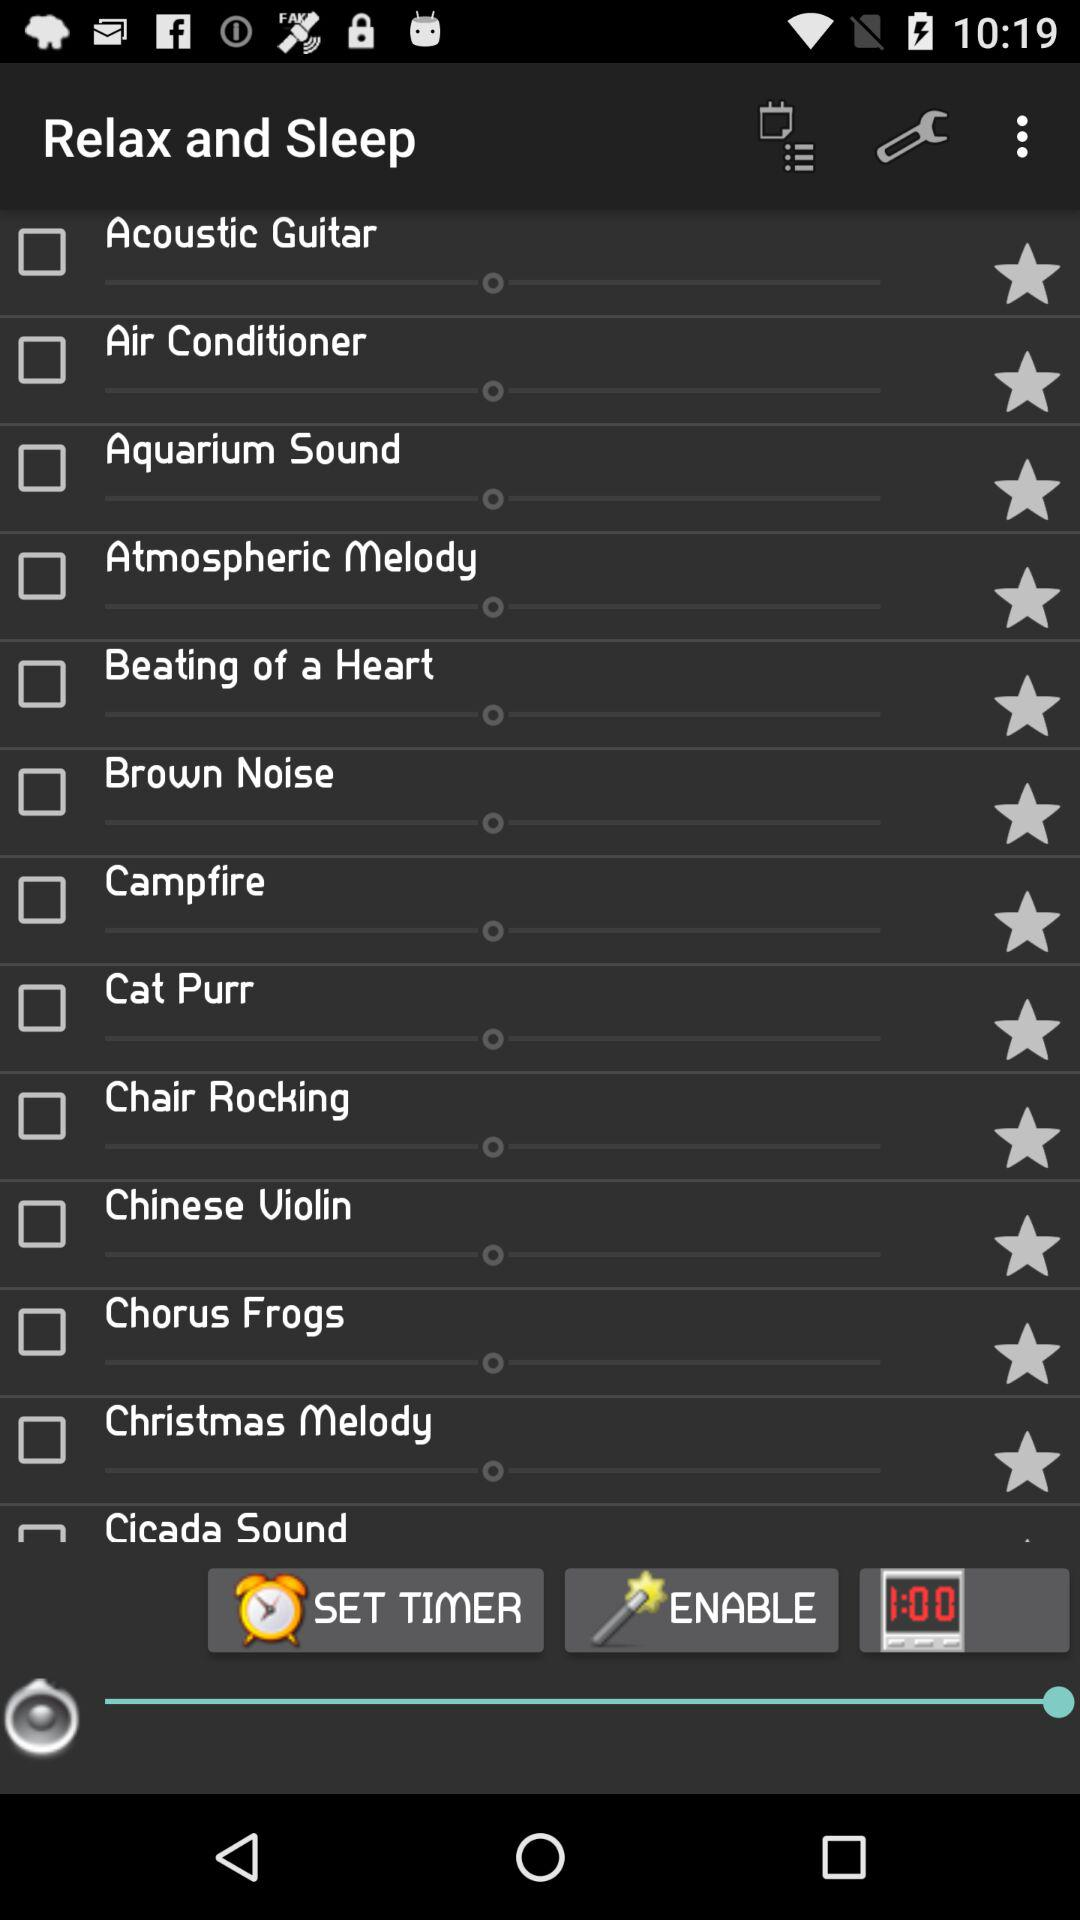What is the status of "Chair Rocking"? The status is off. 